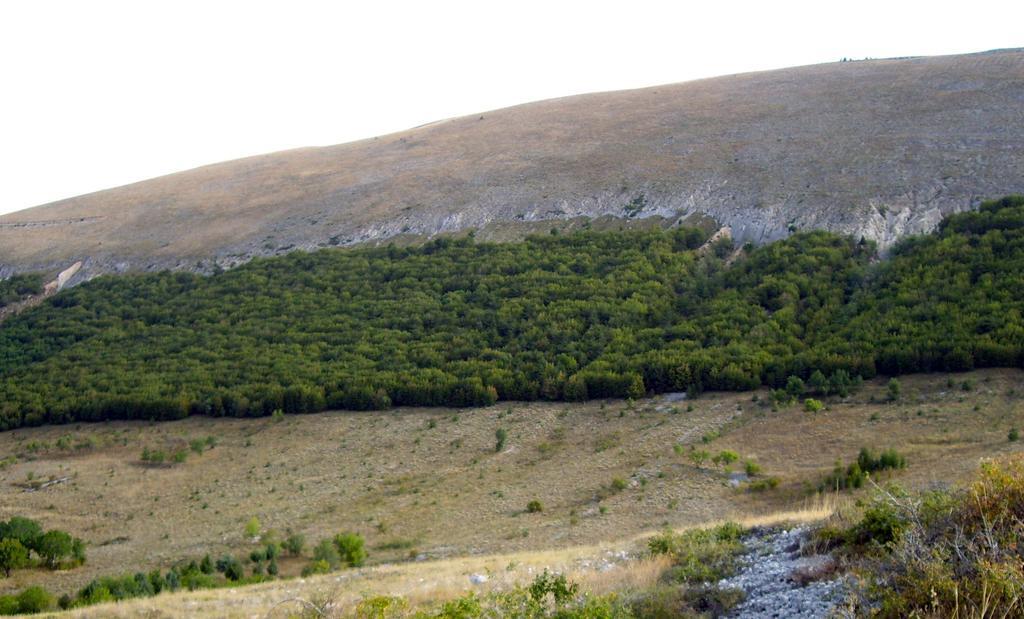How would you summarize this image in a sentence or two? In this image there are few trees on the grassland. Background there is a hill. Top of the image there is sky. Right bottom there are few rocks on the land. 